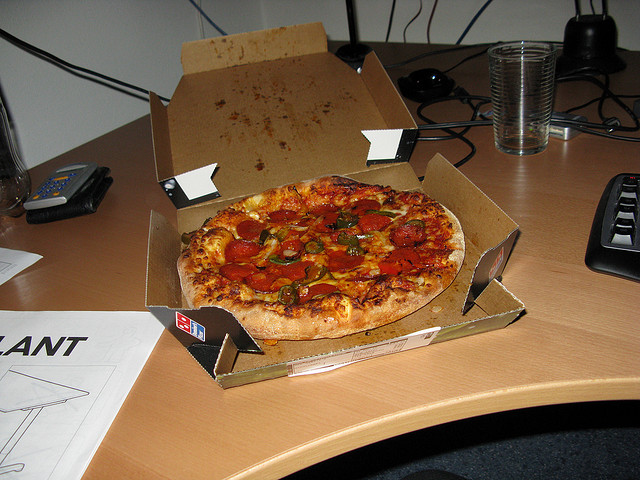Please describe any signs of activity you can see around the workspace. The workspace shows several signs of recent activity. There's a clear glass of water which is nearly full, indicating recent or impending use. The scattered papers and drawings behind the pizza box suggest an environment of ongoing project work or creative brainstorming. The presence of a wallet and calculator next to each other could imply recent financial transactions or budget planning tasks. 